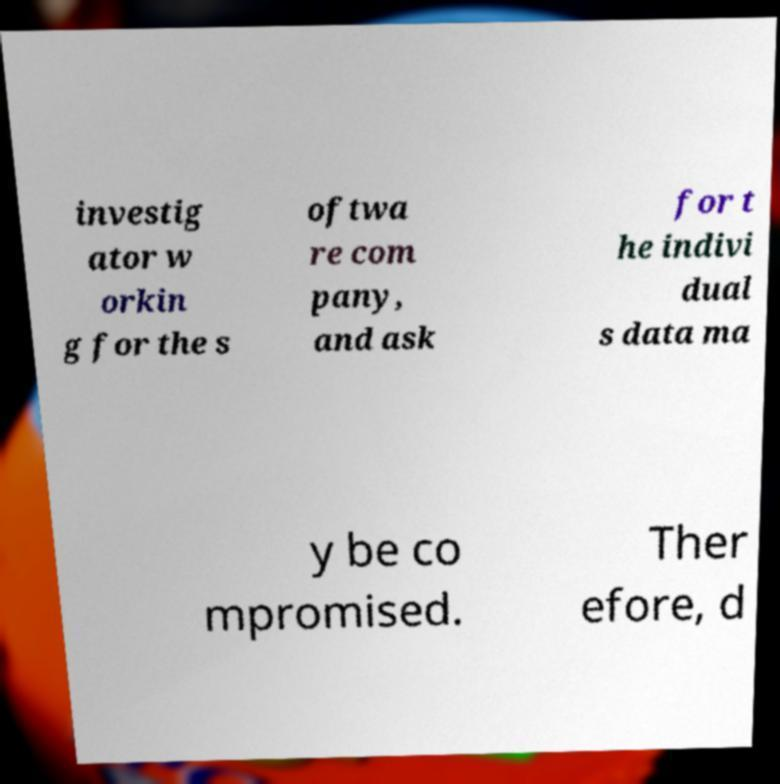Please identify and transcribe the text found in this image. investig ator w orkin g for the s oftwa re com pany, and ask for t he indivi dual s data ma y be co mpromised. Ther efore, d 